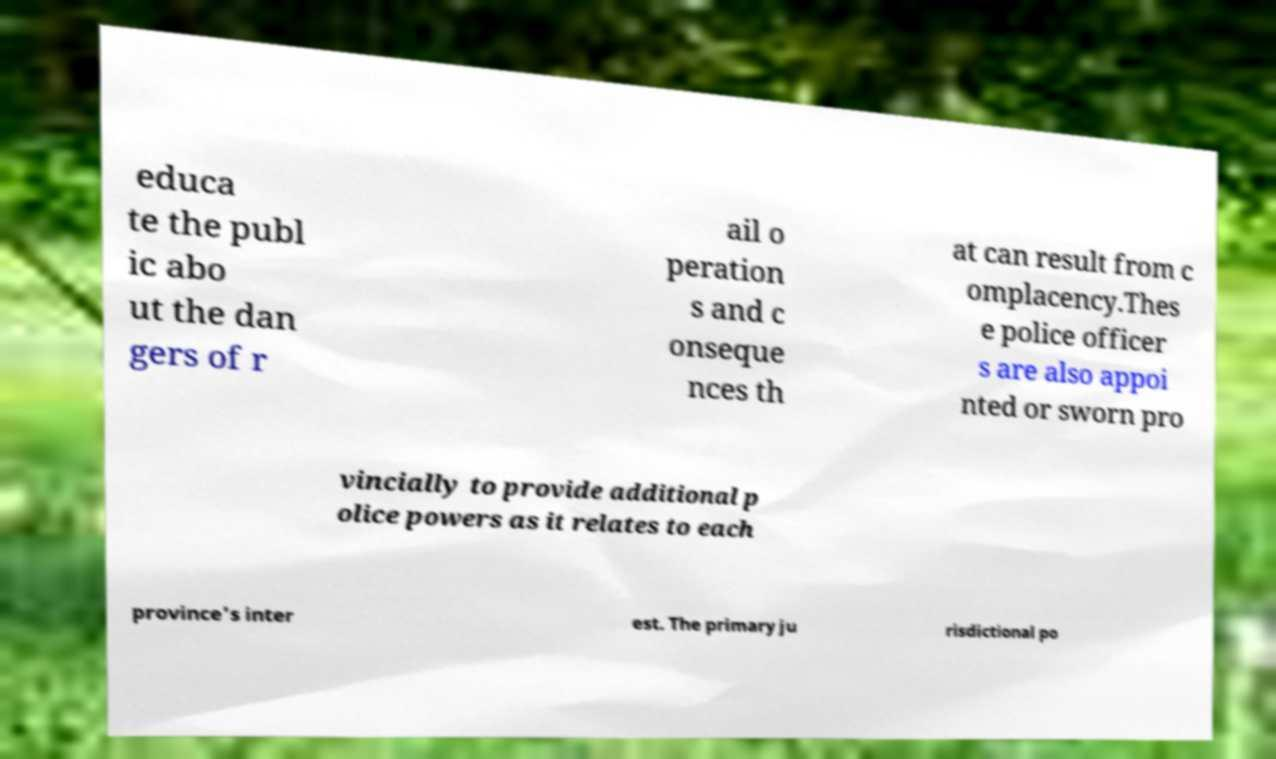I need the written content from this picture converted into text. Can you do that? educa te the publ ic abo ut the dan gers of r ail o peration s and c onseque nces th at can result from c omplacency.Thes e police officer s are also appoi nted or sworn pro vincially to provide additional p olice powers as it relates to each province's inter est. The primary ju risdictional po 